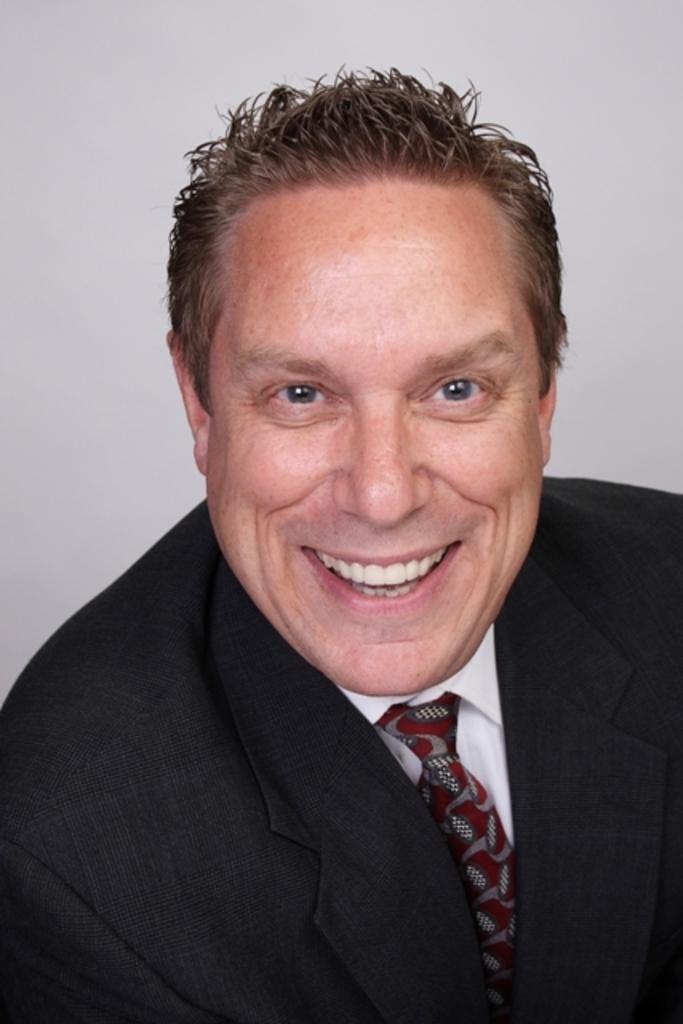Describe this image in one or two sentences. In this picture I can see a man and I can see smile on his face and I can see plain background. 